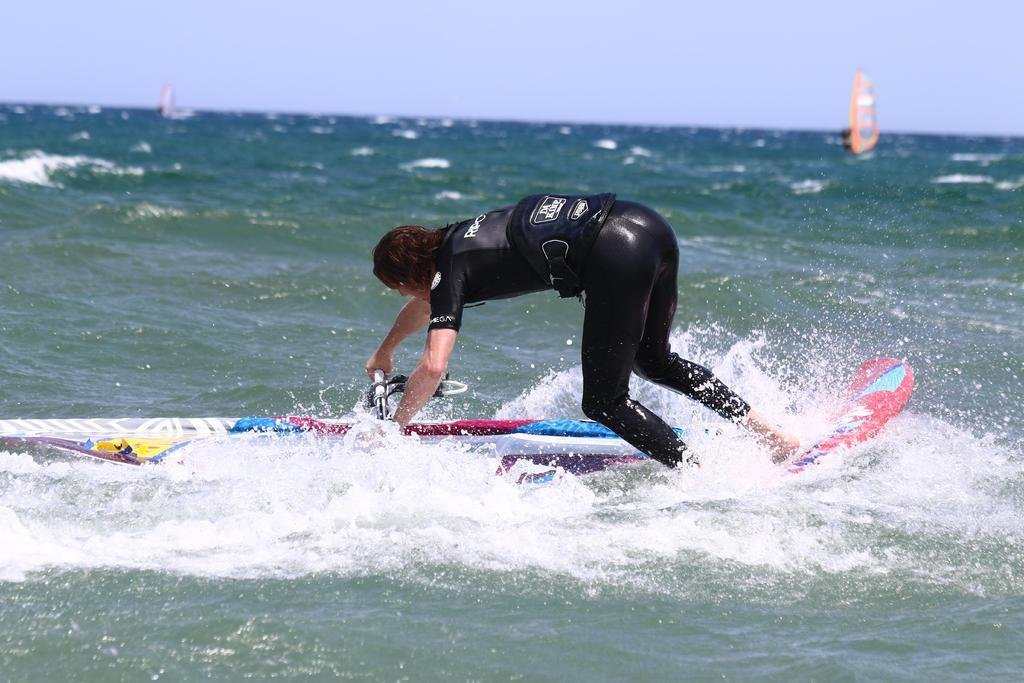What is the main subject of the image? There is a person in the image. What is the person wearing? The person is wearing clothes. What activity is the person engaged in? The person is riding on a surfboard. Where is the surfboard located? The surfboard is on the water. What natural elements can be seen in the image? There is sea and sky visible in the image. What type of earthquake can be seen in the image? There is no earthquake present in the image. What is the governor doing in the image? There is no governor present in the image. 